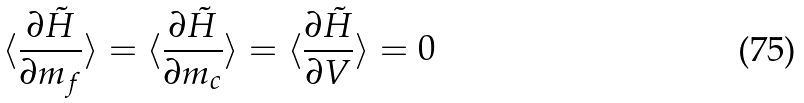<formula> <loc_0><loc_0><loc_500><loc_500>\langle \frac { \partial \tilde { H } } { \partial m _ { f } } \rangle = \langle \frac { \partial \tilde { H } } { \partial m _ { c } } \rangle = \langle \frac { \partial \tilde { H } } { \partial V } \rangle = 0</formula> 